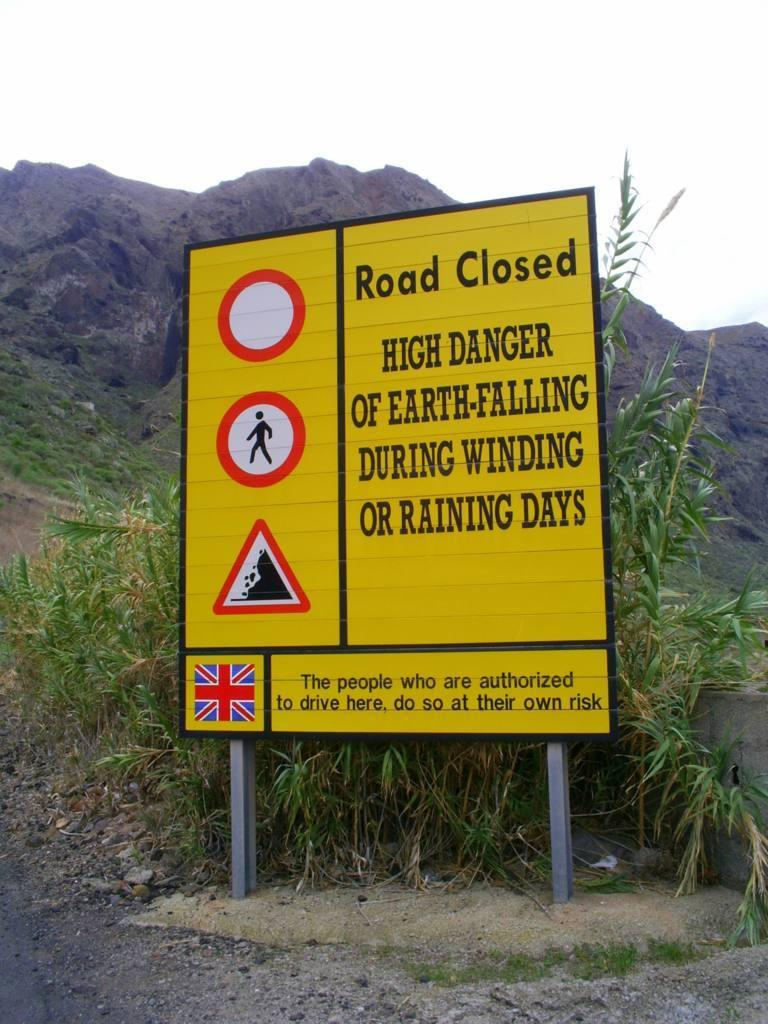<image>
Relay a brief, clear account of the picture shown. A road sign warns motorists of falling earth on windy and rainy days. 